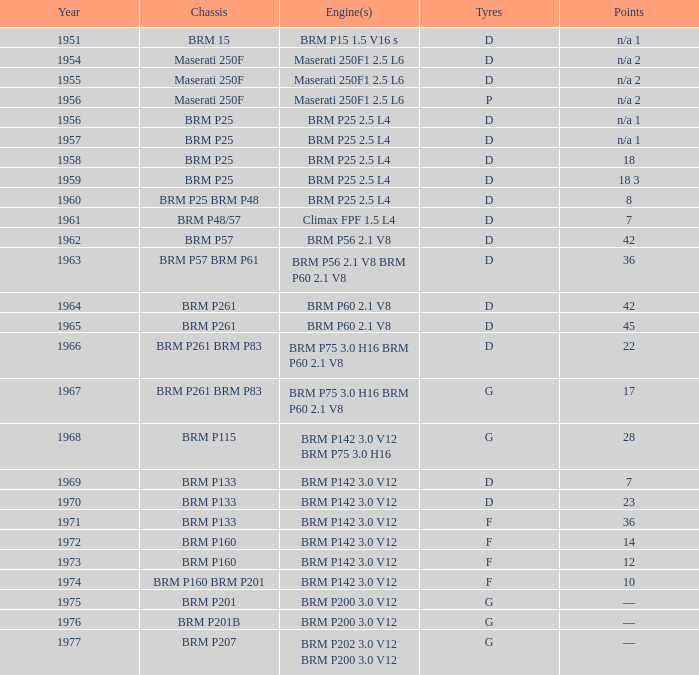What is the significant event for 1974? 10.0. 